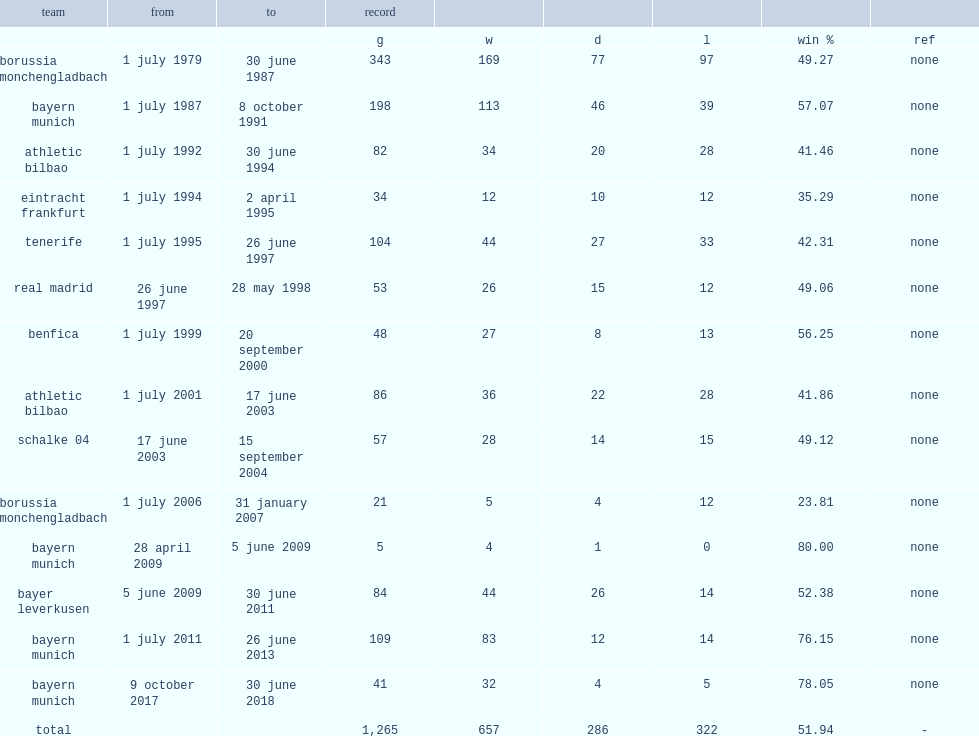How many matches did heynckes manage totally? 1265.0. 